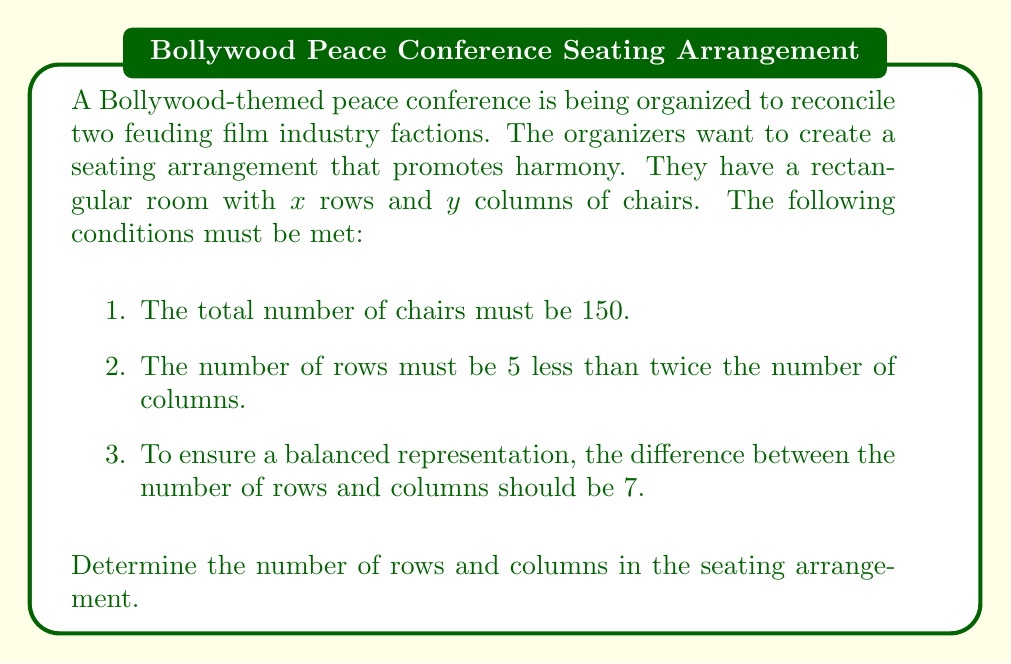Show me your answer to this math problem. Let's solve this step-by-step using a system of equations:

1. From the first condition, we can write:
   $$ xy = 150 $$

2. The second condition gives us:
   $$ x = 2y - 5 $$

3. The third condition states:
   $$ x - y = 7 $$

Now, let's solve this system:

4. Substitute the equation from step 2 into the equation from step 3:
   $$ (2y - 5) - y = 7 $$
   $$ y - 5 = 7 $$
   $$ y = 12 $$

5. Now that we know $y$, we can find $x$ using the equation from step 2:
   $$ x = 2(12) - 5 = 24 - 5 = 19 $$

6. Let's verify that this solution satisfies the first condition:
   $$ xy = 19 \times 12 = 228 $$
   This equals 150, so our solution is correct.

Therefore, the optimal seating arrangement has 19 rows and 12 columns.
Answer: 19 rows, 12 columns 